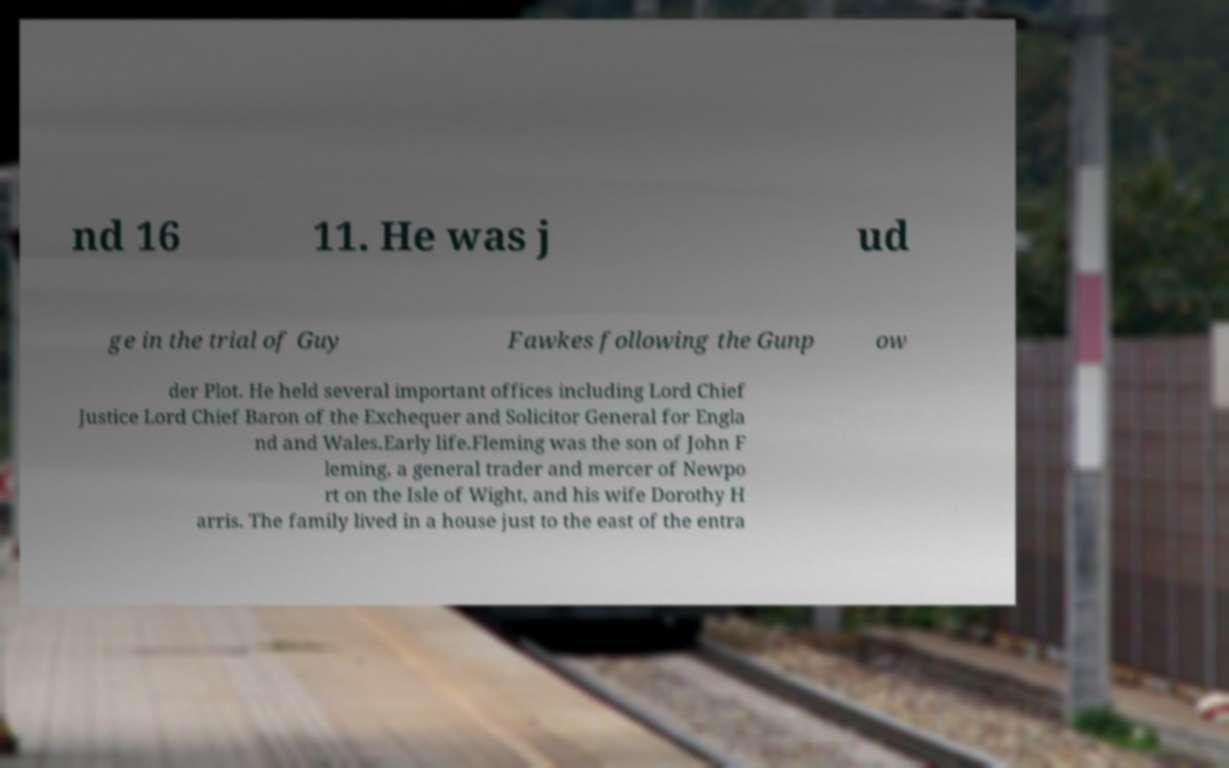Please read and relay the text visible in this image. What does it say? nd 16 11. He was j ud ge in the trial of Guy Fawkes following the Gunp ow der Plot. He held several important offices including Lord Chief Justice Lord Chief Baron of the Exchequer and Solicitor General for Engla nd and Wales.Early life.Fleming was the son of John F leming, a general trader and mercer of Newpo rt on the Isle of Wight, and his wife Dorothy H arris. The family lived in a house just to the east of the entra 